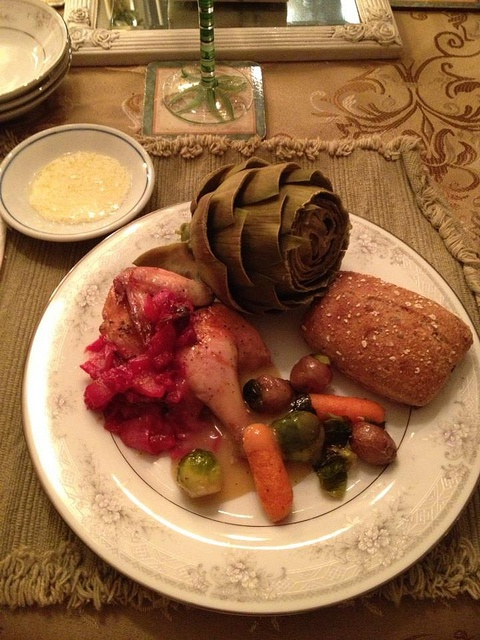Describe the objects in this image and their specific colors. I can see bowl in tan tones, wine glass in tan and olive tones, bowl in tan and khaki tones, carrot in tan, brown, red, and maroon tones, and carrot in tan, brown, red, and maroon tones in this image. 